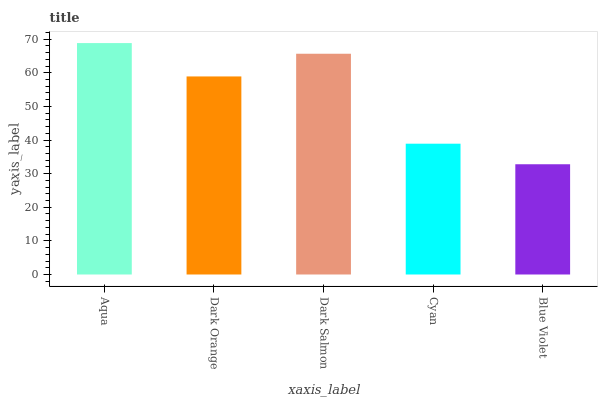Is Blue Violet the minimum?
Answer yes or no. Yes. Is Aqua the maximum?
Answer yes or no. Yes. Is Dark Orange the minimum?
Answer yes or no. No. Is Dark Orange the maximum?
Answer yes or no. No. Is Aqua greater than Dark Orange?
Answer yes or no. Yes. Is Dark Orange less than Aqua?
Answer yes or no. Yes. Is Dark Orange greater than Aqua?
Answer yes or no. No. Is Aqua less than Dark Orange?
Answer yes or no. No. Is Dark Orange the high median?
Answer yes or no. Yes. Is Dark Orange the low median?
Answer yes or no. Yes. Is Dark Salmon the high median?
Answer yes or no. No. Is Dark Salmon the low median?
Answer yes or no. No. 